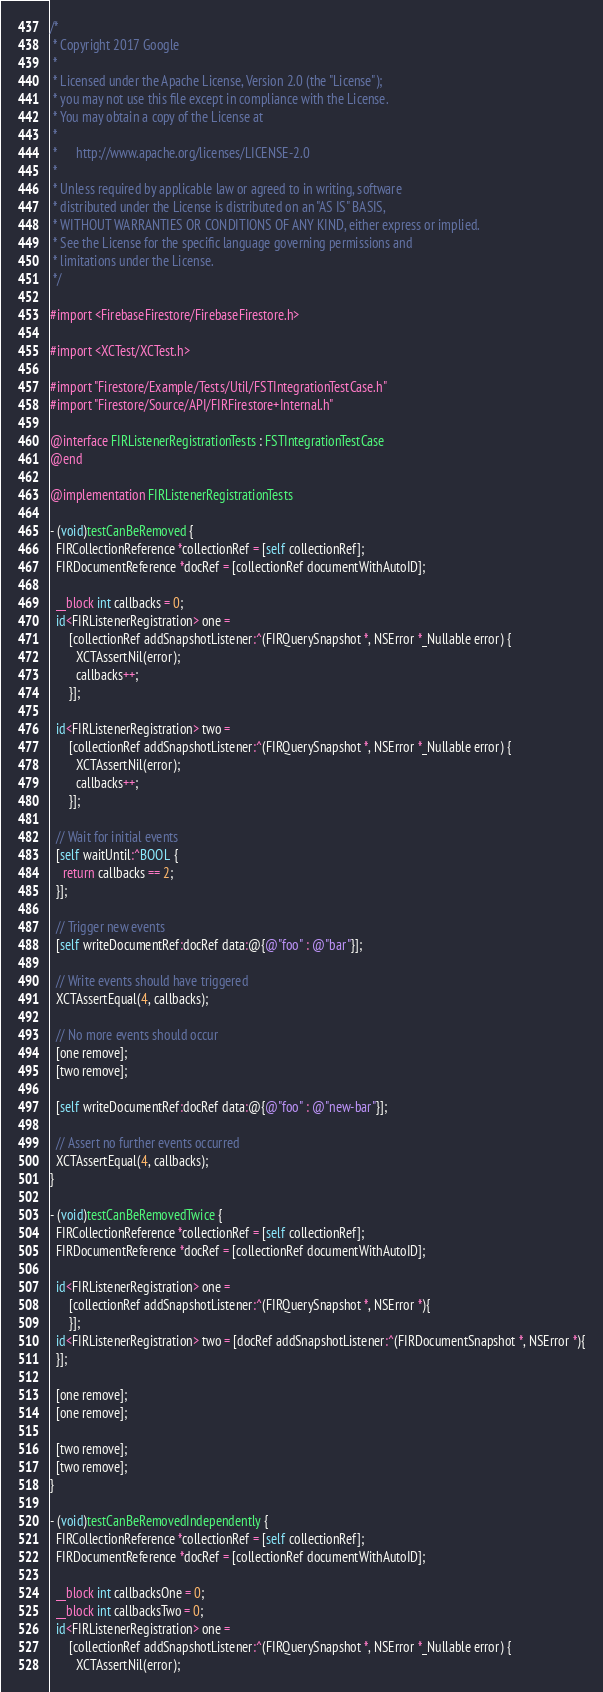Convert code to text. <code><loc_0><loc_0><loc_500><loc_500><_ObjectiveC_>/*
 * Copyright 2017 Google
 *
 * Licensed under the Apache License, Version 2.0 (the "License");
 * you may not use this file except in compliance with the License.
 * You may obtain a copy of the License at
 *
 *      http://www.apache.org/licenses/LICENSE-2.0
 *
 * Unless required by applicable law or agreed to in writing, software
 * distributed under the License is distributed on an "AS IS" BASIS,
 * WITHOUT WARRANTIES OR CONDITIONS OF ANY KIND, either express or implied.
 * See the License for the specific language governing permissions and
 * limitations under the License.
 */

#import <FirebaseFirestore/FirebaseFirestore.h>

#import <XCTest/XCTest.h>

#import "Firestore/Example/Tests/Util/FSTIntegrationTestCase.h"
#import "Firestore/Source/API/FIRFirestore+Internal.h"

@interface FIRListenerRegistrationTests : FSTIntegrationTestCase
@end

@implementation FIRListenerRegistrationTests

- (void)testCanBeRemoved {
  FIRCollectionReference *collectionRef = [self collectionRef];
  FIRDocumentReference *docRef = [collectionRef documentWithAutoID];

  __block int callbacks = 0;
  id<FIRListenerRegistration> one =
      [collectionRef addSnapshotListener:^(FIRQuerySnapshot *, NSError *_Nullable error) {
        XCTAssertNil(error);
        callbacks++;
      }];

  id<FIRListenerRegistration> two =
      [collectionRef addSnapshotListener:^(FIRQuerySnapshot *, NSError *_Nullable error) {
        XCTAssertNil(error);
        callbacks++;
      }];

  // Wait for initial events
  [self waitUntil:^BOOL {
    return callbacks == 2;
  }];

  // Trigger new events
  [self writeDocumentRef:docRef data:@{@"foo" : @"bar"}];

  // Write events should have triggered
  XCTAssertEqual(4, callbacks);

  // No more events should occur
  [one remove];
  [two remove];

  [self writeDocumentRef:docRef data:@{@"foo" : @"new-bar"}];

  // Assert no further events occurred
  XCTAssertEqual(4, callbacks);
}

- (void)testCanBeRemovedTwice {
  FIRCollectionReference *collectionRef = [self collectionRef];
  FIRDocumentReference *docRef = [collectionRef documentWithAutoID];

  id<FIRListenerRegistration> one =
      [collectionRef addSnapshotListener:^(FIRQuerySnapshot *, NSError *){
      }];
  id<FIRListenerRegistration> two = [docRef addSnapshotListener:^(FIRDocumentSnapshot *, NSError *){
  }];

  [one remove];
  [one remove];

  [two remove];
  [two remove];
}

- (void)testCanBeRemovedIndependently {
  FIRCollectionReference *collectionRef = [self collectionRef];
  FIRDocumentReference *docRef = [collectionRef documentWithAutoID];

  __block int callbacksOne = 0;
  __block int callbacksTwo = 0;
  id<FIRListenerRegistration> one =
      [collectionRef addSnapshotListener:^(FIRQuerySnapshot *, NSError *_Nullable error) {
        XCTAssertNil(error);</code> 